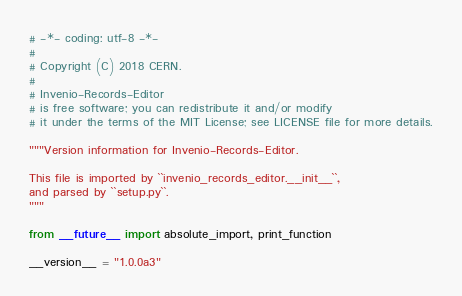Convert code to text. <code><loc_0><loc_0><loc_500><loc_500><_Python_># -*- coding: utf-8 -*-
#
# Copyright (C) 2018 CERN.
#
# Invenio-Records-Editor
# is free software; you can redistribute it and/or modify
# it under the terms of the MIT License; see LICENSE file for more details.

"""Version information for Invenio-Records-Editor.

This file is imported by ``invenio_records_editor.__init__``,
and parsed by ``setup.py``.
"""

from __future__ import absolute_import, print_function

__version__ = "1.0.0a3"
</code> 